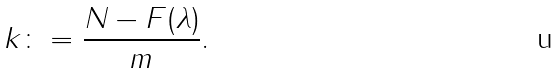<formula> <loc_0><loc_0><loc_500><loc_500>k \colon = \frac { N - F ( \lambda ) } { m } .</formula> 